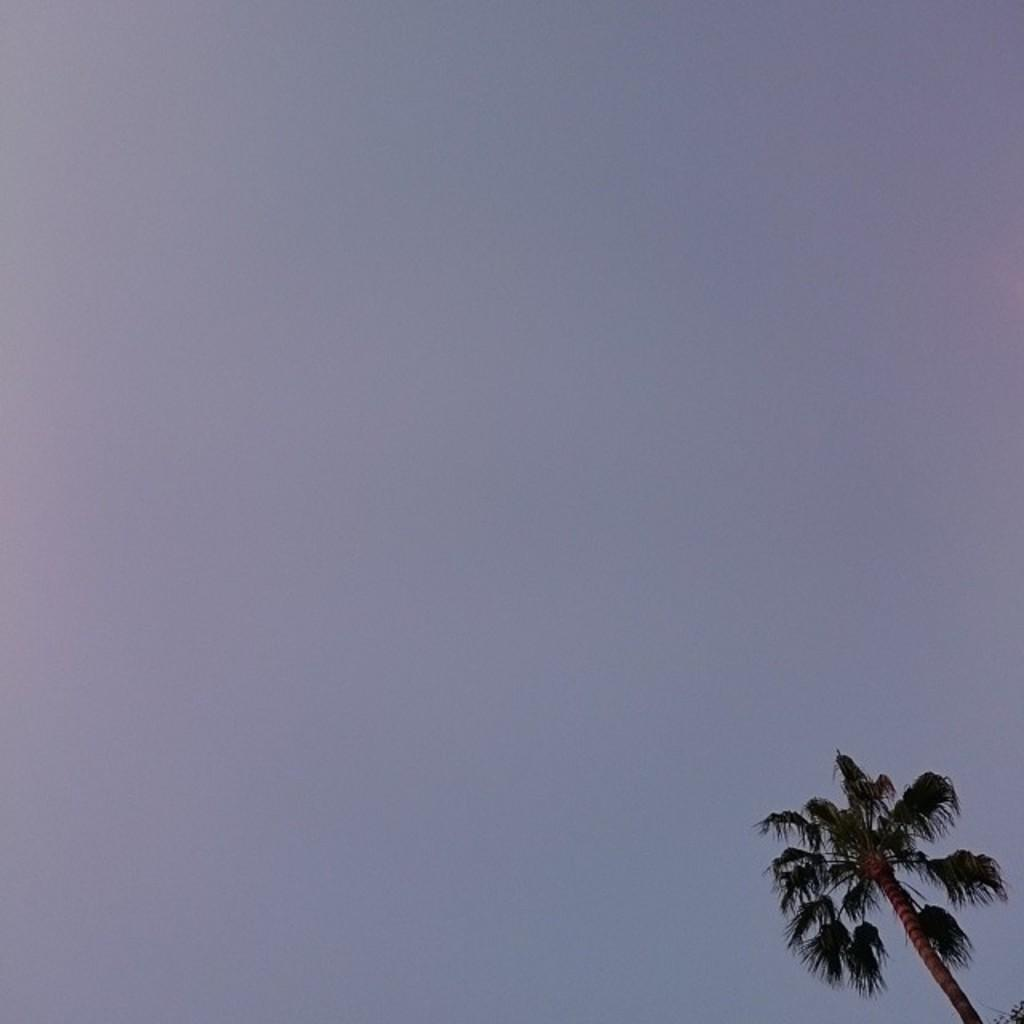What type of plant can be seen in the image? There is a tree in the image. What part of the natural environment is visible in the image? The sky is visible in the background of the image. How many giants are holding the tree in the image? There are no giants present in the image, and therefore no such activity can be observed. What type of bear can be seen climbing the tree in the image? There are no bears present in the image, and therefore no such activity can be observed. 